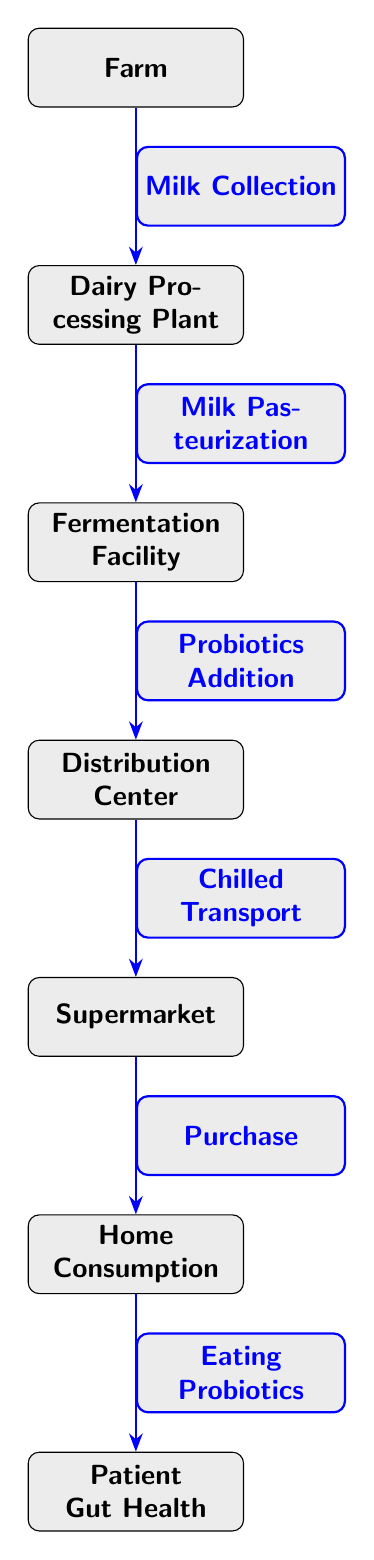What's the first node in the food chain? The diagram starts at the "Farm," which is the first node in the food chain.
Answer: Farm How many nodes are there in total? By counting each distinct location or process represented in the diagram, there are six nodes: Farm, Dairy Processing Plant, Fermentation Facility, Distribution Center, Supermarket, and Home Consumption.
Answer: 6 What process follows "Milk Collection"? The process that comes immediately after "Milk Collection" is "Milk Pasteurization," which is the next step in the food chain.
Answer: Milk Pasteurization Which node represents the final destination impacting gut health? The final node listed in the diagram, which is essential for gut health, is "Patient Gut Health." This indicates that the overall aim of the food chain is to contribute positively to gut health.
Answer: Patient Gut Health What is transported from the Distribution Center to the Supermarket? The transportation process from the Distribution Center to the Supermarket is described as "Chilled Transport," ensuring that the products maintain appropriate temperature.
Answer: Chilled Transport Which two nodes are involved in adding probiotics? The nodes involved in the addition of probiotics are "Fermentation Facility" (where probiotics are added) and "Distribution Center" (where the product moves to after fermentation) since this is where the processed probiotic foods are sent.
Answer: Fermentation Facility and Distribution Center What action occurs at the "Home Consumption" node? At the "Home Consumption" node, the action taking place is "Eating Probiotics," which refers to the act of consuming those probiotic-rich foods.
Answer: Eating Probiotics What is the relationship between the "Supermarket" and the "Home Consumption" nodes? The relationship is defined by the action "Purchase," indicating that consumers buy probiotic products at the Supermarket before consuming them at home.
Answer: Purchase 